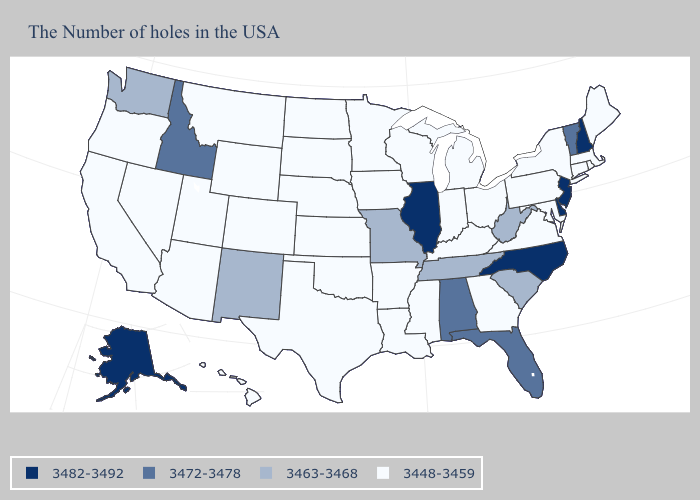Which states hav the highest value in the West?
Be succinct. Alaska. Name the states that have a value in the range 3472-3478?
Give a very brief answer. Vermont, Florida, Alabama, Idaho. Does Alaska have the lowest value in the West?
Give a very brief answer. No. What is the value of Oregon?
Give a very brief answer. 3448-3459. Name the states that have a value in the range 3448-3459?
Give a very brief answer. Maine, Massachusetts, Rhode Island, Connecticut, New York, Maryland, Pennsylvania, Virginia, Ohio, Georgia, Michigan, Kentucky, Indiana, Wisconsin, Mississippi, Louisiana, Arkansas, Minnesota, Iowa, Kansas, Nebraska, Oklahoma, Texas, South Dakota, North Dakota, Wyoming, Colorado, Utah, Montana, Arizona, Nevada, California, Oregon, Hawaii. What is the lowest value in states that border Massachusetts?
Answer briefly. 3448-3459. Name the states that have a value in the range 3448-3459?
Quick response, please. Maine, Massachusetts, Rhode Island, Connecticut, New York, Maryland, Pennsylvania, Virginia, Ohio, Georgia, Michigan, Kentucky, Indiana, Wisconsin, Mississippi, Louisiana, Arkansas, Minnesota, Iowa, Kansas, Nebraska, Oklahoma, Texas, South Dakota, North Dakota, Wyoming, Colorado, Utah, Montana, Arizona, Nevada, California, Oregon, Hawaii. What is the value of North Dakota?
Give a very brief answer. 3448-3459. Does the map have missing data?
Write a very short answer. No. What is the value of Colorado?
Be succinct. 3448-3459. What is the value of Pennsylvania?
Be succinct. 3448-3459. Does North Carolina have the same value as Hawaii?
Answer briefly. No. Does Missouri have the lowest value in the USA?
Quick response, please. No. Name the states that have a value in the range 3472-3478?
Give a very brief answer. Vermont, Florida, Alabama, Idaho. What is the value of New Mexico?
Keep it brief. 3463-3468. 